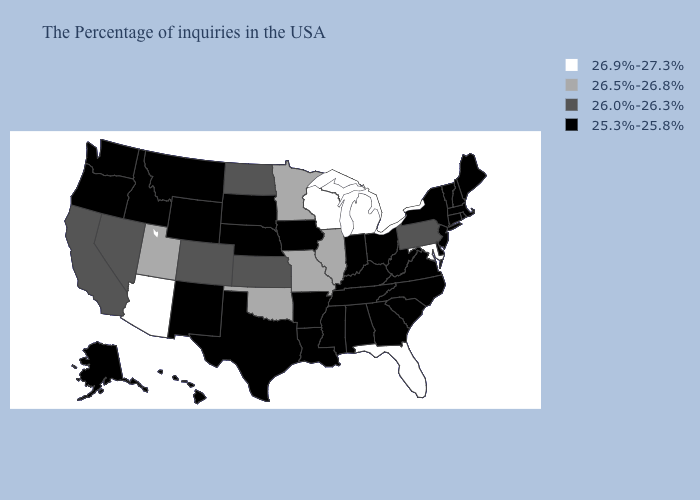Name the states that have a value in the range 26.5%-26.8%?
Concise answer only. Illinois, Missouri, Minnesota, Oklahoma, Utah. Which states have the lowest value in the MidWest?
Give a very brief answer. Ohio, Indiana, Iowa, Nebraska, South Dakota. Does Pennsylvania have the lowest value in the USA?
Keep it brief. No. What is the lowest value in the USA?
Answer briefly. 25.3%-25.8%. What is the value of Colorado?
Short answer required. 26.0%-26.3%. Does Utah have the same value as Pennsylvania?
Give a very brief answer. No. Does Vermont have the same value as Kansas?
Be succinct. No. Does Kentucky have the highest value in the USA?
Concise answer only. No. Which states have the lowest value in the USA?
Concise answer only. Maine, Massachusetts, Rhode Island, New Hampshire, Vermont, Connecticut, New York, New Jersey, Delaware, Virginia, North Carolina, South Carolina, West Virginia, Ohio, Georgia, Kentucky, Indiana, Alabama, Tennessee, Mississippi, Louisiana, Arkansas, Iowa, Nebraska, Texas, South Dakota, Wyoming, New Mexico, Montana, Idaho, Washington, Oregon, Alaska, Hawaii. Does Indiana have a higher value than West Virginia?
Be succinct. No. What is the value of New York?
Write a very short answer. 25.3%-25.8%. Which states hav the highest value in the South?
Keep it brief. Maryland, Florida. Among the states that border Maryland , does Pennsylvania have the lowest value?
Give a very brief answer. No. Among the states that border New Hampshire , which have the lowest value?
Concise answer only. Maine, Massachusetts, Vermont. 